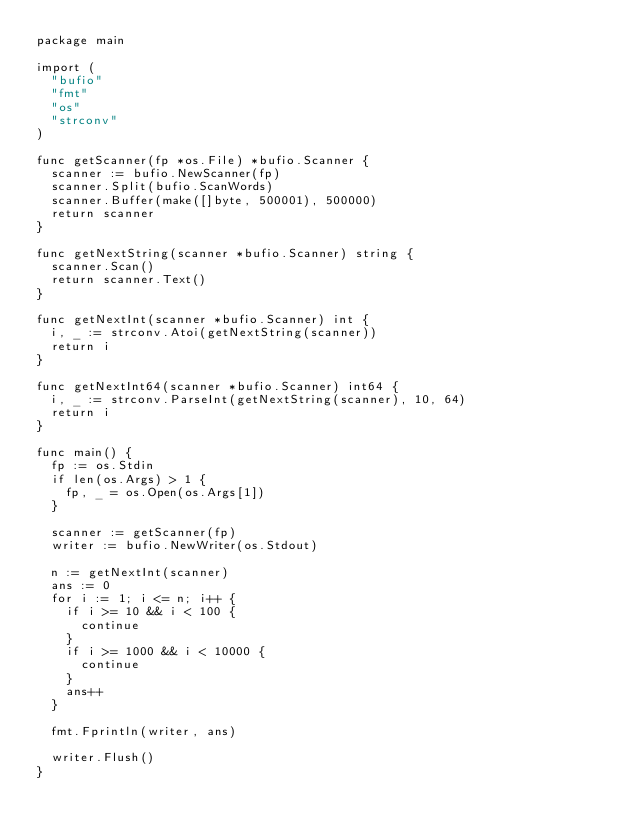Convert code to text. <code><loc_0><loc_0><loc_500><loc_500><_Go_>package main

import (
	"bufio"
	"fmt"
	"os"
	"strconv"
)

func getScanner(fp *os.File) *bufio.Scanner {
	scanner := bufio.NewScanner(fp)
	scanner.Split(bufio.ScanWords)
	scanner.Buffer(make([]byte, 500001), 500000)
	return scanner
}

func getNextString(scanner *bufio.Scanner) string {
	scanner.Scan()
	return scanner.Text()
}

func getNextInt(scanner *bufio.Scanner) int {
	i, _ := strconv.Atoi(getNextString(scanner))
	return i
}

func getNextInt64(scanner *bufio.Scanner) int64 {
	i, _ := strconv.ParseInt(getNextString(scanner), 10, 64)
	return i
}

func main() {
	fp := os.Stdin
	if len(os.Args) > 1 {
		fp, _ = os.Open(os.Args[1])
	}

	scanner := getScanner(fp)
	writer := bufio.NewWriter(os.Stdout)

	n := getNextInt(scanner)
	ans := 0
	for i := 1; i <= n; i++ {
		if i >= 10 && i < 100 {
			continue
		}
		if i >= 1000 && i < 10000 {
			continue
		}
		ans++
	}

	fmt.Fprintln(writer, ans)

	writer.Flush()
}
</code> 